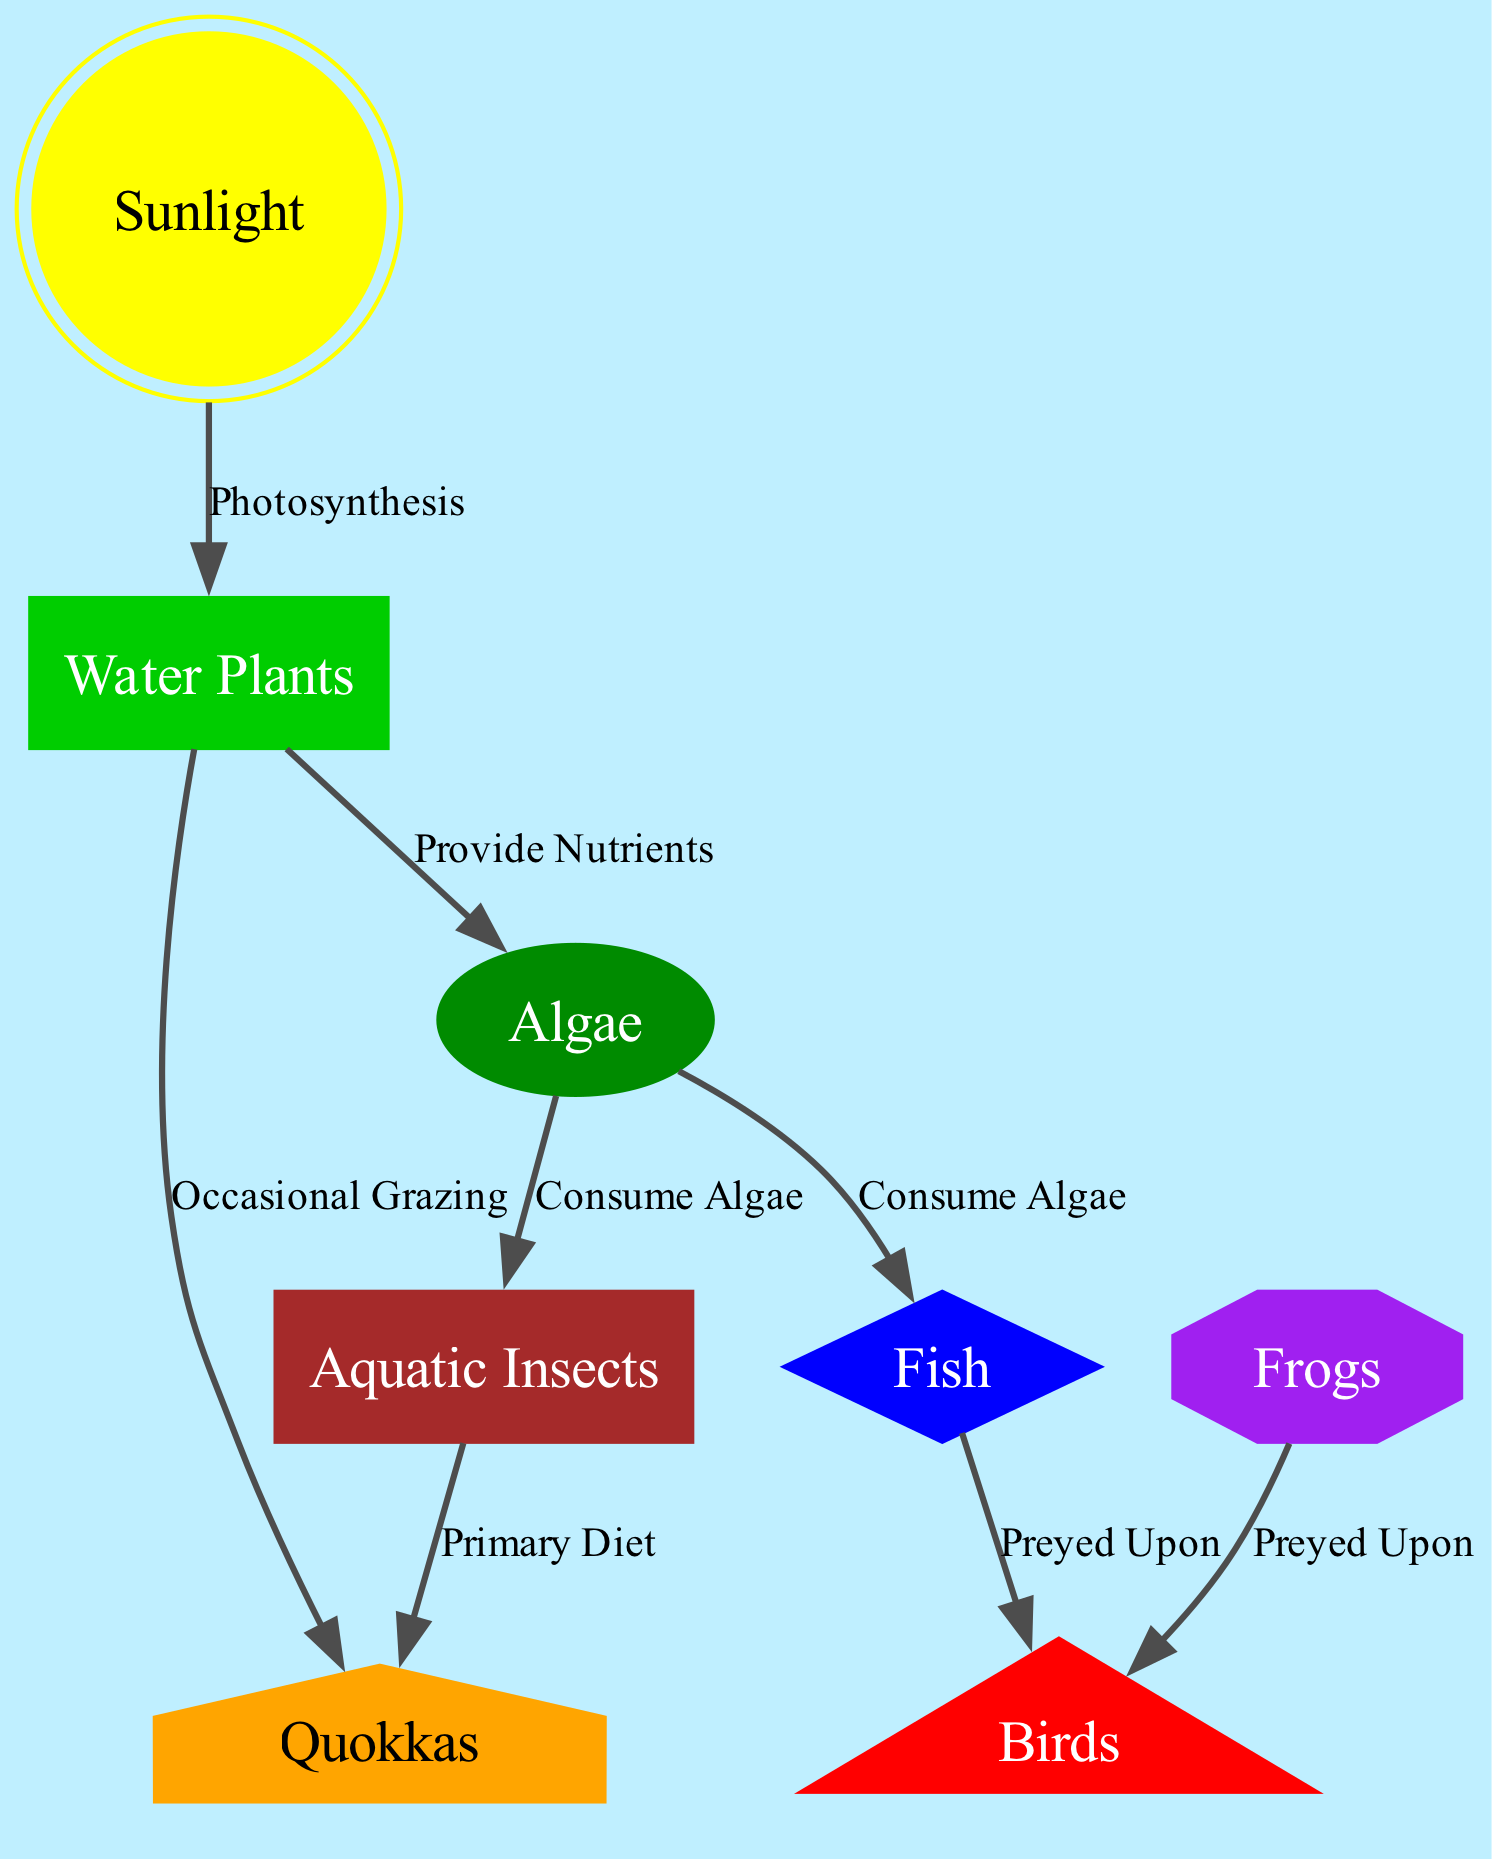What is the primary producer in this food chain? The primary producer in the food chain is the node that directly uses sunlight to create energy through photosynthesis. From the diagram, that node is "Water Plants."
Answer: Water Plants How many nodes are present in the diagram? To determine the total number of nodes, we simply count each unique node, which includes Sunlight, Water Plants, Algae, Aquatic Insects, Quokkas, Birds, Fish, and Frogs. This totals to 8 nodes.
Answer: 8 What consumes Algae? The diagram indicates that both "Aquatic Insects" and "Fish" have an edge labeled "Consume Algae" coming from the "Algae" node. Hence, there are two entities that consume Algae.
Answer: Aquatic Insects, Fish How are Quokkas primarily fed? The edges leading into the "Quokkas" node show two relationships: one from "Aquatic Insects," labeled "Primary Diet," and another from "Water Plants," labeled "Occasional Grazing." This means that Quokkas are primarily fed by consuming both Aquatic Insects and Water Plants.
Answer: Aquatic Insects, Water Plants Which node is preyed upon by both Birds and Frogs? By examining the edges, we can see that both "Birds" and "Frogs" have an edge directed towards "Aquatic Insects," indicating that this is the node that is preyed upon by both of them.
Answer: Aquatic Insects 